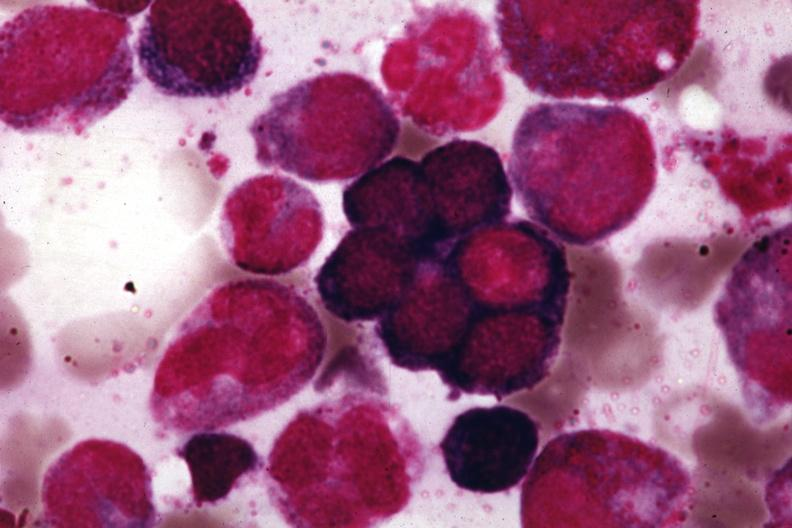what does this image show?
Answer the question using a single word or phrase. Wrights 